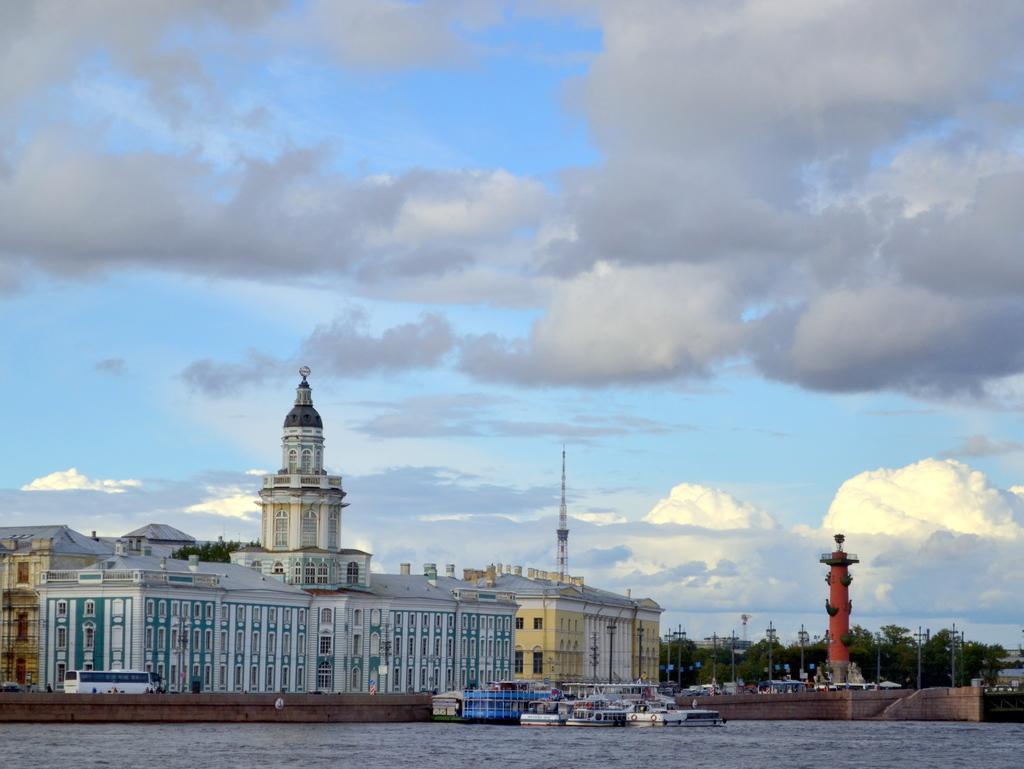How would you summarize this image in a sentence or two? In this picture we can see a building here, at the bottom there is water, we can see some boats here, there is a tower here, in the background there are some trees, we can see the sky at the top of the picture. 